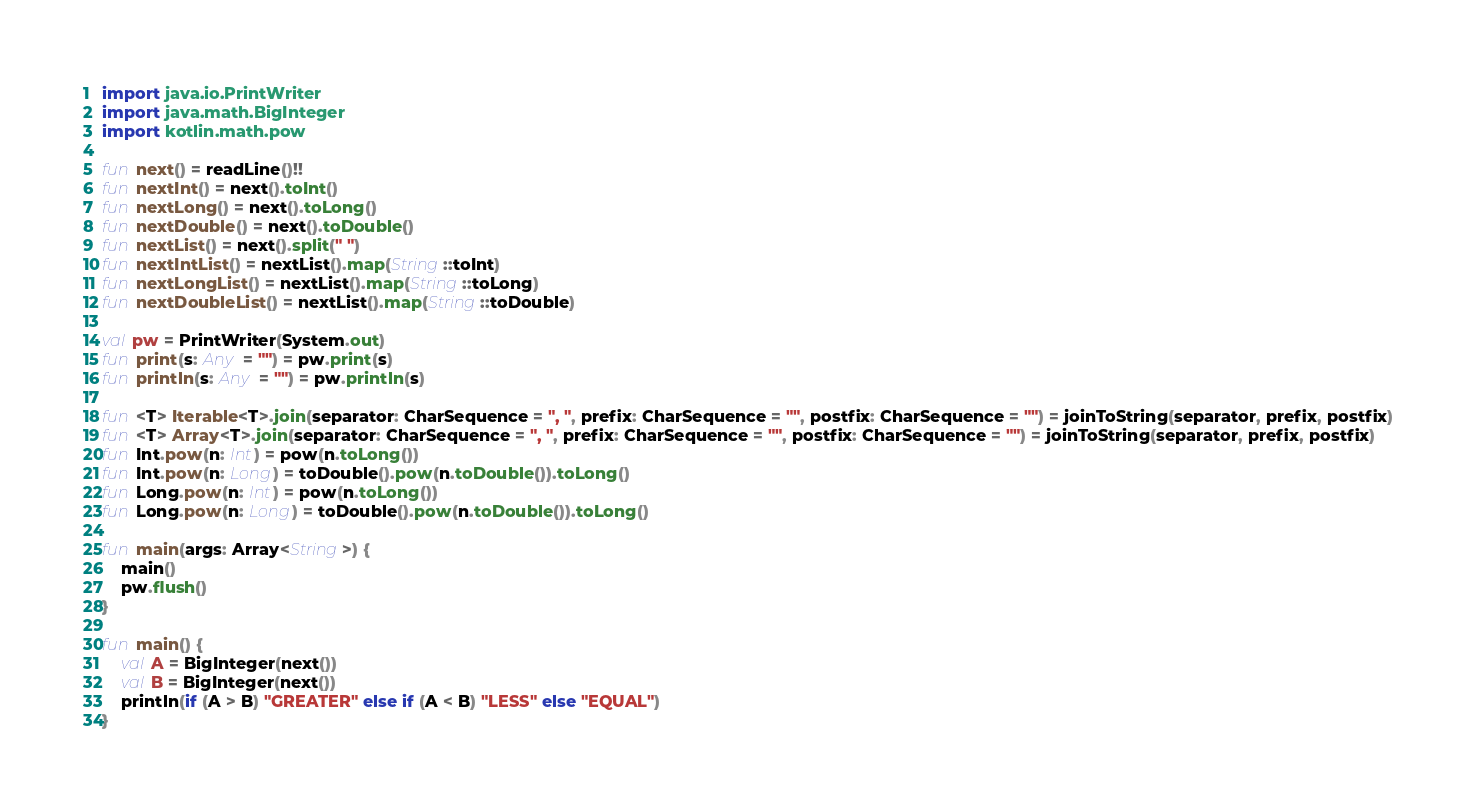<code> <loc_0><loc_0><loc_500><loc_500><_Kotlin_>import java.io.PrintWriter
import java.math.BigInteger
import kotlin.math.pow

fun next() = readLine()!!
fun nextInt() = next().toInt()
fun nextLong() = next().toLong()
fun nextDouble() = next().toDouble()
fun nextList() = next().split(" ")
fun nextIntList() = nextList().map(String::toInt)
fun nextLongList() = nextList().map(String::toLong)
fun nextDoubleList() = nextList().map(String::toDouble)

val pw = PrintWriter(System.out)
fun print(s: Any = "") = pw.print(s)
fun println(s: Any = "") = pw.println(s)

fun <T> Iterable<T>.join(separator: CharSequence = ", ", prefix: CharSequence = "", postfix: CharSequence = "") = joinToString(separator, prefix, postfix)
fun <T> Array<T>.join(separator: CharSequence = ", ", prefix: CharSequence = "", postfix: CharSequence = "") = joinToString(separator, prefix, postfix)
fun Int.pow(n: Int) = pow(n.toLong())
fun Int.pow(n: Long) = toDouble().pow(n.toDouble()).toLong()
fun Long.pow(n: Int) = pow(n.toLong())
fun Long.pow(n: Long) = toDouble().pow(n.toDouble()).toLong()

fun main(args: Array<String>) {
    main()
    pw.flush()
}

fun main() {
    val A = BigInteger(next())
    val B = BigInteger(next())
    println(if (A > B) "GREATER" else if (A < B) "LESS" else "EQUAL")
}</code> 